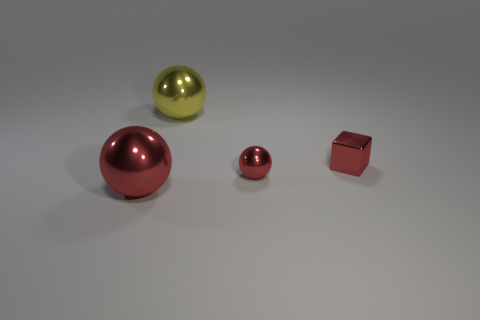The block that is the same color as the tiny sphere is what size?
Make the answer very short. Small. Does the yellow ball to the left of the red block have the same size as the tiny sphere?
Ensure brevity in your answer.  No. There is a small red object that is in front of the block; what is its shape?
Keep it short and to the point. Sphere. Are there more small metallic balls than green spheres?
Keep it short and to the point. Yes. There is a shiny thing on the left side of the big yellow metallic sphere; is its color the same as the cube?
Offer a very short reply. Yes. What number of things are either large balls in front of the large yellow metallic thing or red objects behind the big red shiny thing?
Offer a very short reply. 3. How many things are both behind the small red metallic ball and on the right side of the yellow thing?
Your response must be concise. 1. Is the yellow ball made of the same material as the tiny block?
Offer a very short reply. Yes. What is the shape of the big metallic thing that is in front of the large metallic object behind the large object that is in front of the yellow metallic ball?
Provide a succinct answer. Sphere. The large metallic object that is to the right of the object to the left of the yellow ball that is right of the large red shiny thing is what color?
Provide a short and direct response. Yellow. 